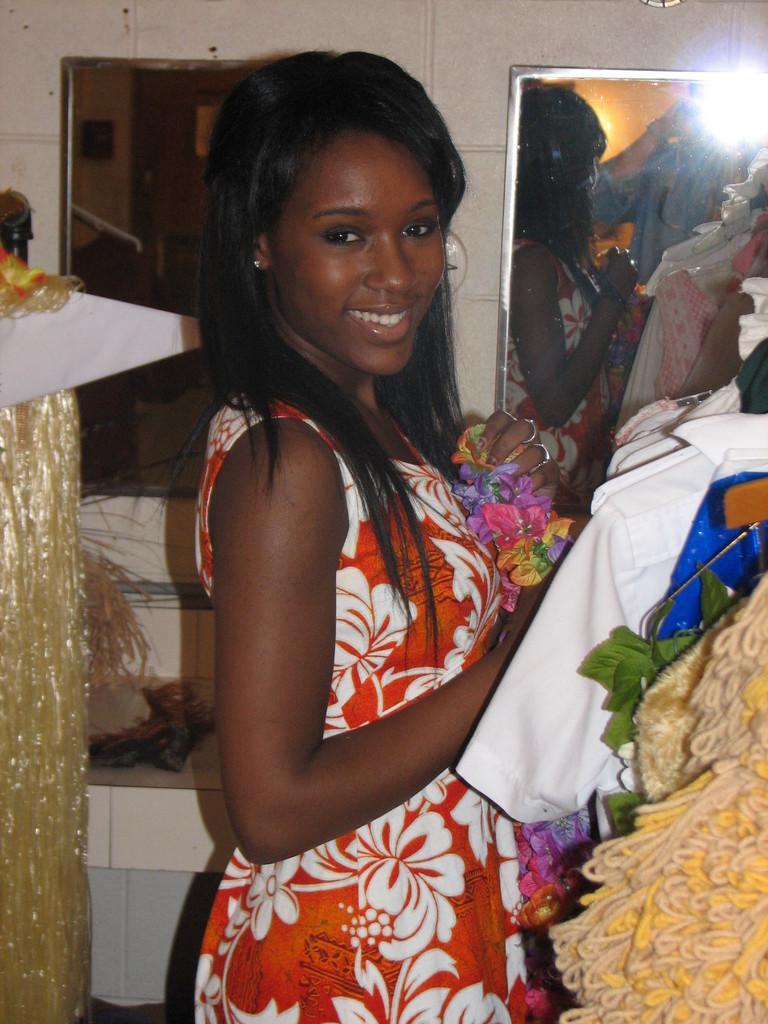Describe this image in one or two sentences. In this image we can see a lady holding flowers. In the back there are mirrors. On the mirror we can see reflection of this lady and another person and there is light. On the right side there are dresses. 